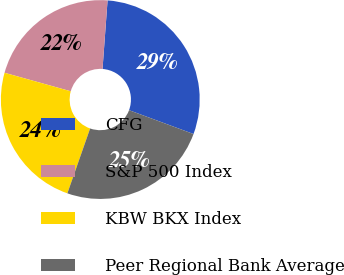Convert chart to OTSL. <chart><loc_0><loc_0><loc_500><loc_500><pie_chart><fcel>CFG<fcel>S&P 500 Index<fcel>KBW BKX Index<fcel>Peer Regional Bank Average<nl><fcel>29.47%<fcel>21.83%<fcel>23.97%<fcel>24.73%<nl></chart> 